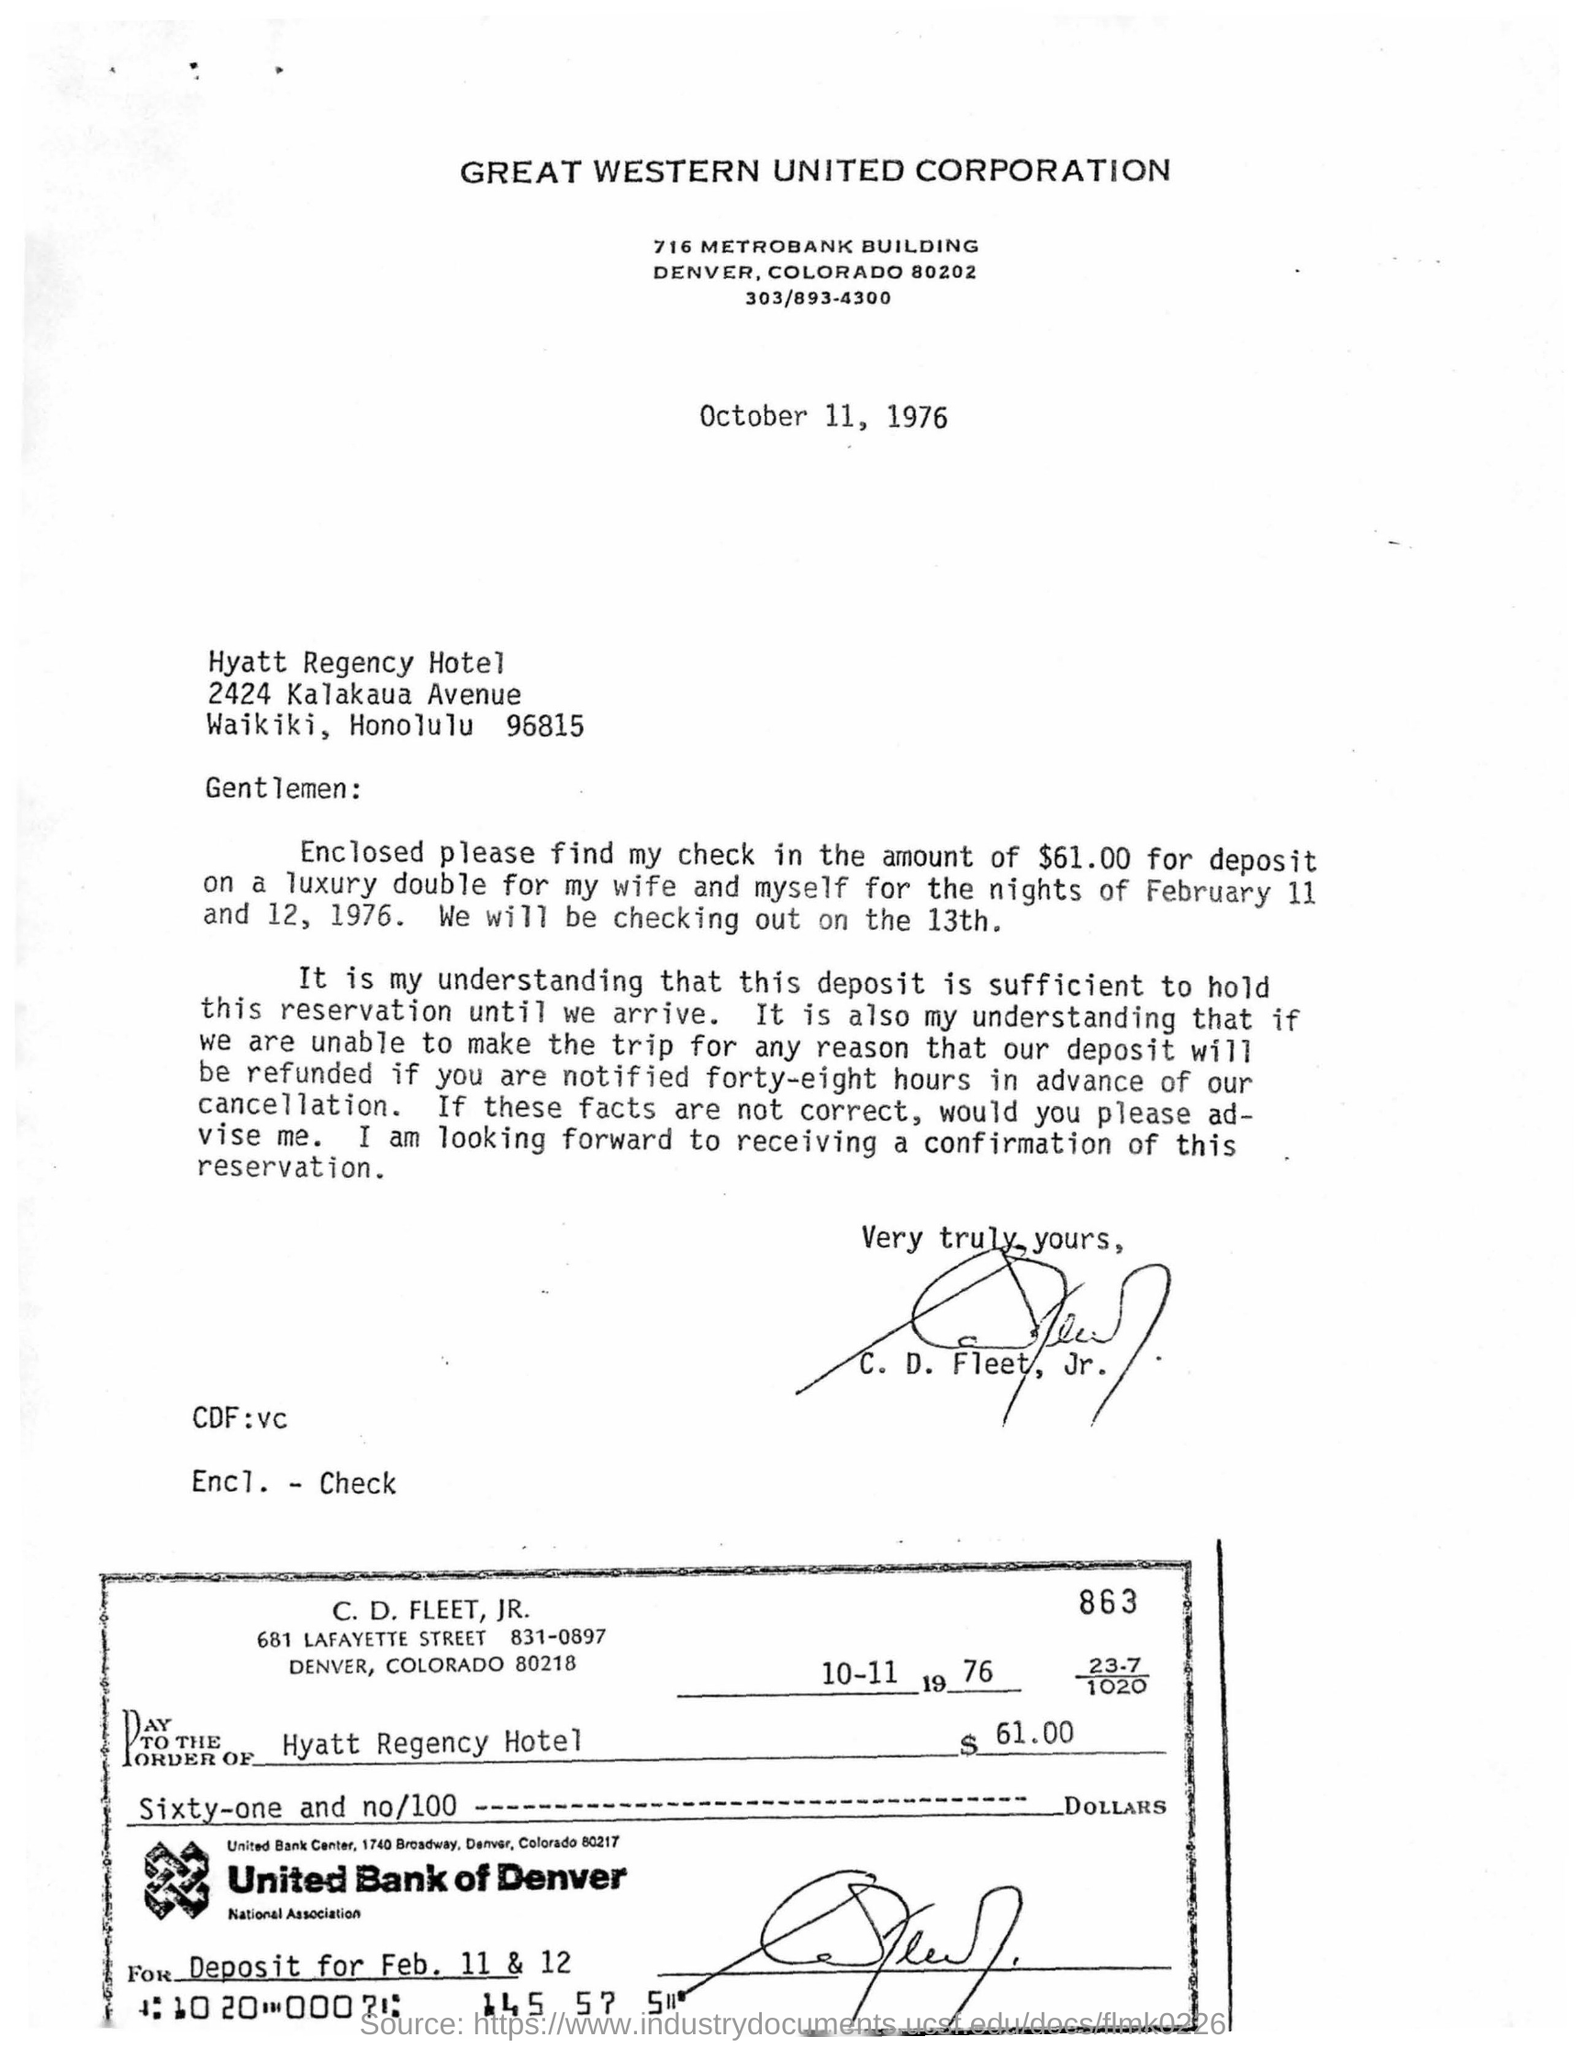What is the name of corporation?
Your answer should be very brief. Great western united corporation. How much amount is deposited for room in hotel by the c.d.fleet ?
Offer a terse response. $61.00. What is the name of the hotel?
Keep it short and to the point. Hyatt Regency Hotel. Whose signature is  in the letter?
Your answer should be compact. C. D. Fleet, Jr. Which bank's name in the check?
Provide a succinct answer. United Bank of Denver. What is the date mentioned in the check?
Provide a short and direct response. 10-11 1976. 